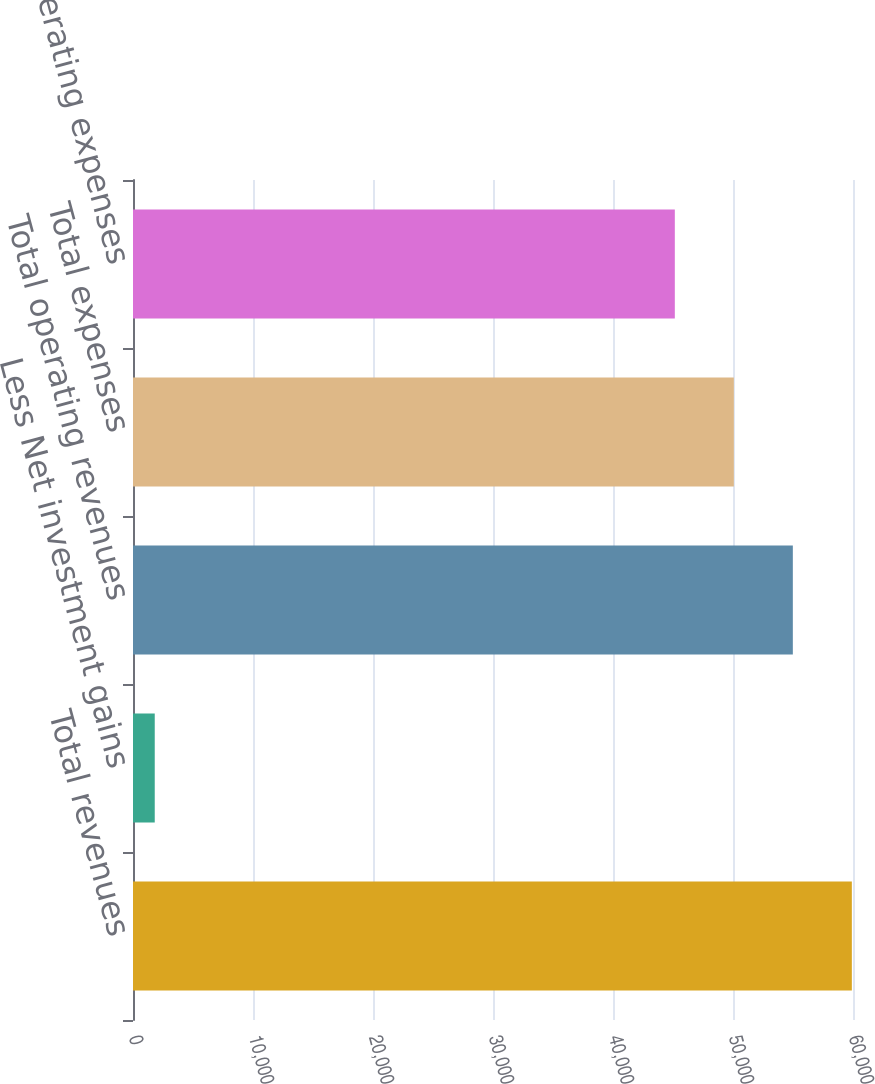Convert chart. <chart><loc_0><loc_0><loc_500><loc_500><bar_chart><fcel>Total revenues<fcel>Less Net investment gains<fcel>Total operating revenues<fcel>Total expenses<fcel>Total operating expenses<nl><fcel>59903.6<fcel>1812<fcel>54986.4<fcel>50069.2<fcel>45152<nl></chart> 